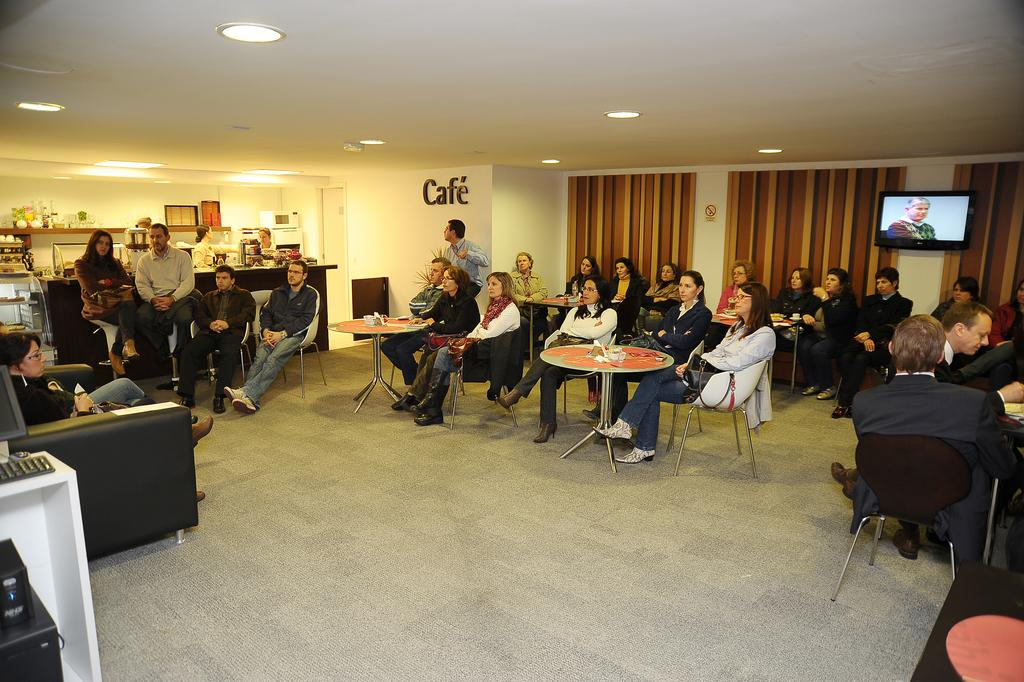What are the people in the image doing? The people in the image are sitting. What objects are in front of the people? The people have tables in front of front of them. What can be seen in the background of the image? There is a television and curtains in the background of the image. What type of sense can be seen in the image? There is no sense present in the image; it features people sitting with tables and a background with a television and curtains. 